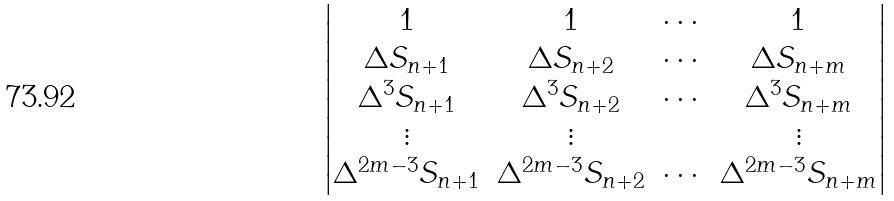<formula> <loc_0><loc_0><loc_500><loc_500>\begin{vmatrix} 1 & 1 & \cdots & 1 \\ \Delta S _ { n + 1 } & \Delta S _ { n + 2 } & \cdots & \Delta S _ { n + m } \\ \Delta ^ { 3 } S _ { n + 1 } & \Delta ^ { 3 } S _ { n + 2 } & \cdots & \Delta ^ { 3 } S _ { n + m } \\ \vdots & \vdots & & \vdots \\ \Delta ^ { 2 m - 3 } S _ { n + 1 } & \Delta ^ { 2 m - 3 } S _ { n + 2 } & \cdots & \Delta ^ { 2 m - 3 } S _ { n + m } \end{vmatrix}</formula> 